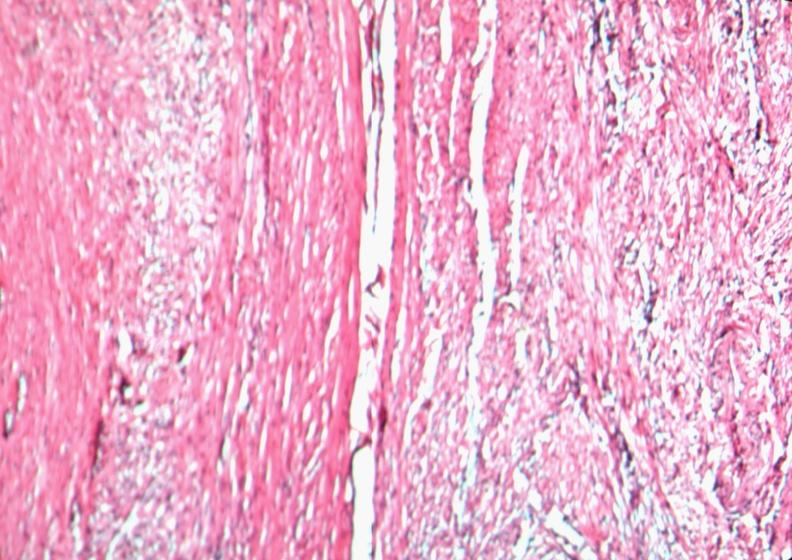what is present?
Answer the question using a single word or phrase. Female reproductive 